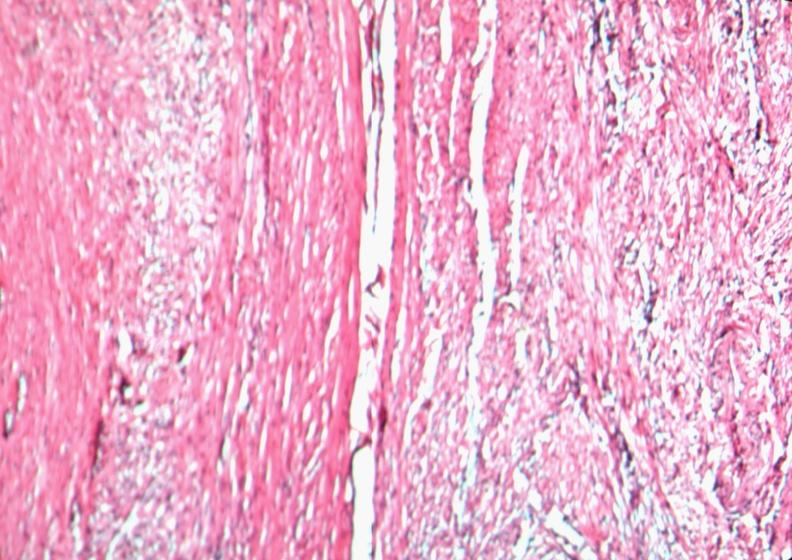what is present?
Answer the question using a single word or phrase. Female reproductive 